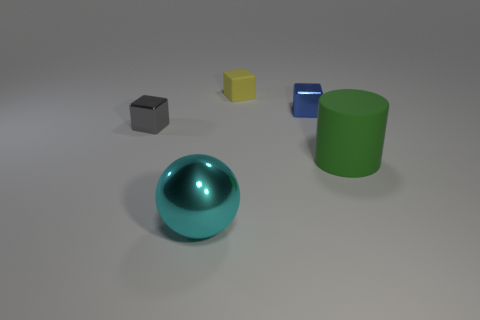Is the material of the gray block the same as the tiny blue object?
Your answer should be very brief. Yes. What number of large spheres are made of the same material as the cylinder?
Provide a succinct answer. 0. There is a rubber object that is the same shape as the gray shiny thing; what size is it?
Make the answer very short. Small. What is the material of the cyan object?
Make the answer very short. Metal. What is the material of the small block that is to the right of the yellow thing behind the block on the left side of the cyan ball?
Give a very brief answer. Metal. Is there anything else that is the same shape as the small blue thing?
Offer a terse response. Yes. There is another metallic object that is the same shape as the tiny gray metallic thing; what color is it?
Offer a terse response. Blue. Is the color of the shiny cube that is to the left of the large metal sphere the same as the metallic thing in front of the large rubber thing?
Your response must be concise. No. Are there more tiny gray shiny objects behind the small matte block than big red matte cylinders?
Ensure brevity in your answer.  No. How many other things are there of the same size as the yellow rubber block?
Your answer should be compact. 2. 